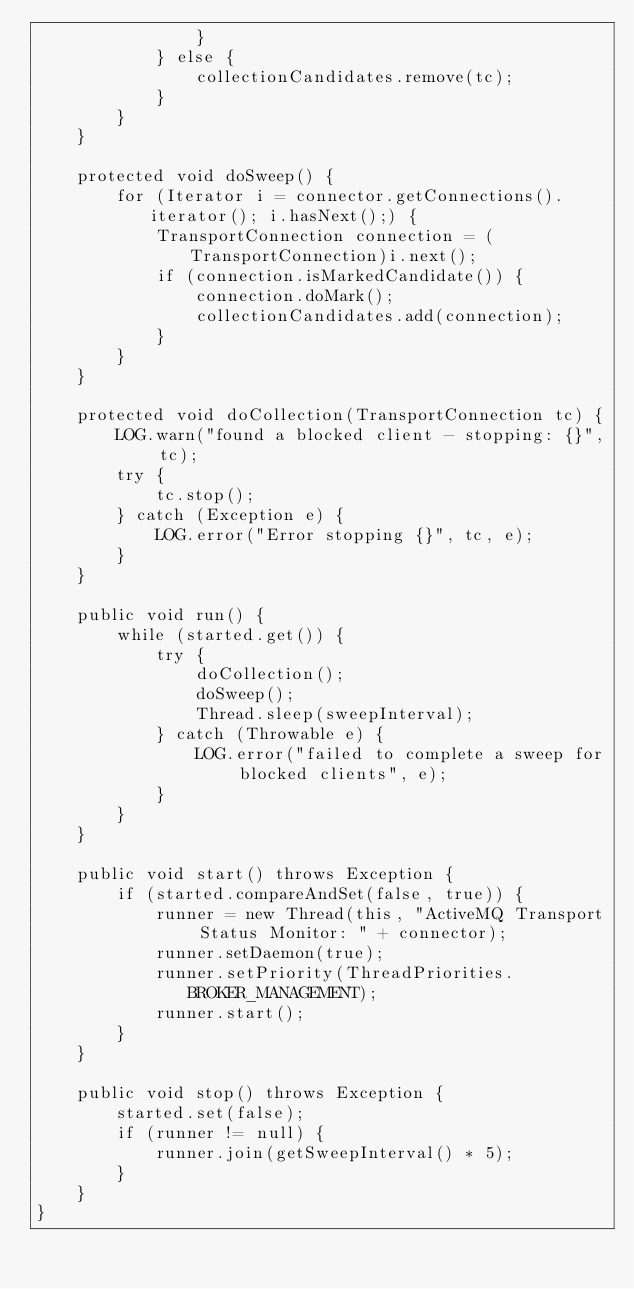<code> <loc_0><loc_0><loc_500><loc_500><_Java_>                }
            } else {
                collectionCandidates.remove(tc);
            }
        }
    }

    protected void doSweep() {
        for (Iterator i = connector.getConnections().iterator(); i.hasNext();) {
            TransportConnection connection = (TransportConnection)i.next();
            if (connection.isMarkedCandidate()) {
                connection.doMark();
                collectionCandidates.add(connection);
            }
        }
    }

    protected void doCollection(TransportConnection tc) {
        LOG.warn("found a blocked client - stopping: {}", tc);
        try {
            tc.stop();
        } catch (Exception e) {
            LOG.error("Error stopping {}", tc, e);
        }
    }

    public void run() {
        while (started.get()) {
            try {
                doCollection();
                doSweep();
                Thread.sleep(sweepInterval);
            } catch (Throwable e) {
                LOG.error("failed to complete a sweep for blocked clients", e);
            }
        }
    }

    public void start() throws Exception {
        if (started.compareAndSet(false, true)) {
            runner = new Thread(this, "ActiveMQ Transport Status Monitor: " + connector);
            runner.setDaemon(true);
            runner.setPriority(ThreadPriorities.BROKER_MANAGEMENT);
            runner.start();
        }
    }

    public void stop() throws Exception {
        started.set(false);
        if (runner != null) {
            runner.join(getSweepInterval() * 5);
        }
    }
}
</code> 